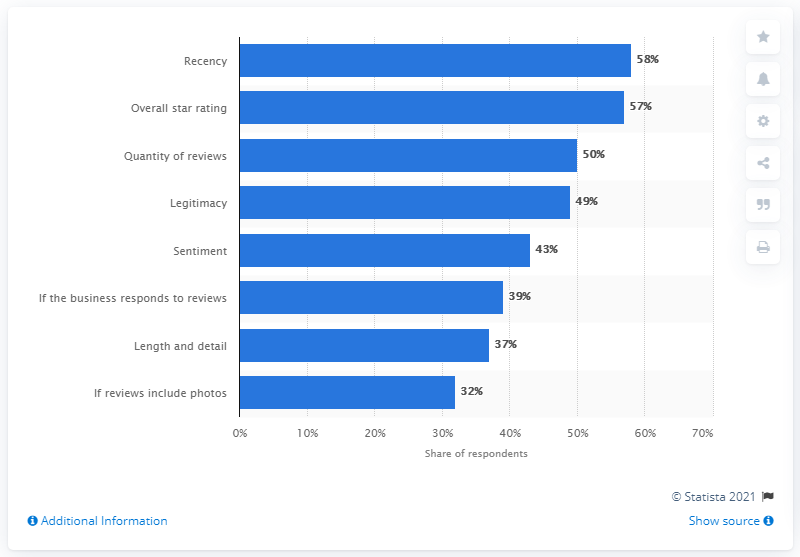Mention a couple of crucial points in this snapshot. The ratio of the most important factor to the least one is 1.8125... The median value of the bars is 46. 